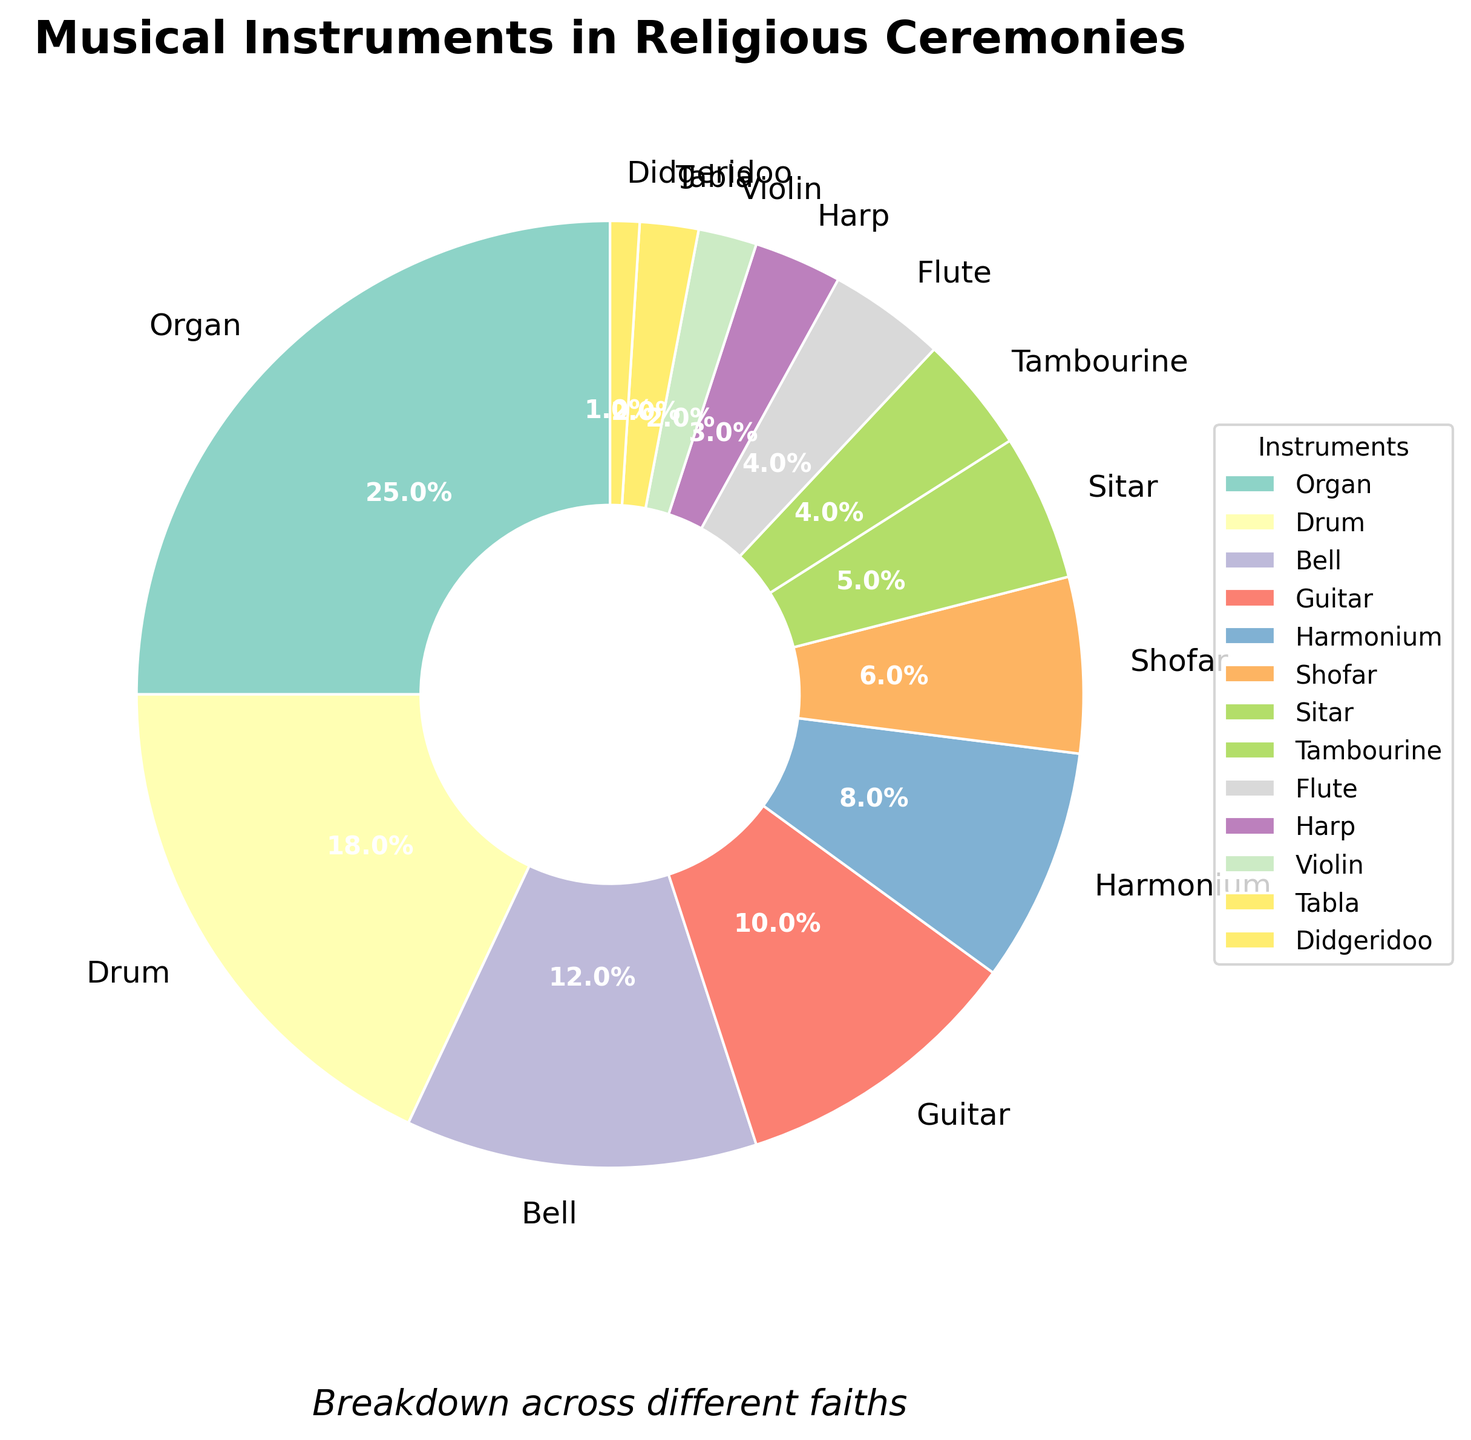What percentage of instruments used in religious ceremonies are percussion instruments (Drum, Tabla, Tambourine)? Add up the respective percentages for Drum (18%), Tabla (2%), and Tambourine (4%) to find the total percentage. 18 + 2 + 4 = 24%
Answer: 24% Which instrument is most commonly used in religious ceremonies based on the pie chart? The instrument with the highest percentage is the most commonly used. From the chart, the Organ has the highest percentage at 25%.
Answer: Organ How much greater is the percentage of Harmoniums compared to Sitars in religious ceremonies? Subtract the percentage of Sitars (5%) from the percentage of Harmoniums (8%). 8 - 5 = 3%
Answer: 3% Which two instruments together make up exactly 10% of the total share? From the chart, both Flute and Tambourine each contribute 4%, and Tabla contributes 2%, adding together to 10%.
Answer: Flute and Tambourine or Violin and Tabla How does the percentage usage of the Shofar compare with that of the Sitar? From the pie chart, the percentage usage of the Shofar (6%) is greater than that of the Sitar (5%). 6% - 5% = 1%
Answer: Shofar has 1% more What is the combined percentage for Bell and Guitar? Add the percentages for Bell (12%) and Guitar (10%). 12 + 10 = 22%
Answer: 22% Which instrument represents the smallest percentage of use in religious ceremonies? The instrument with the smallest percentage in the chart is the Didgeridoo with 1%.
Answer: Didgeridoo If we look at string instruments, which ones are included and what is their total percentage? Identify the string instruments: Guitar (10%), Sitar (5%), Harp (3%), Violin (2%). Their total percentage is 10 + 5 + 3 + 2 = 20%
Answer: Guitar, Sitar, Harp, Violin; 20% How many instruments have a single-digit percentage usage in religious ceremonies? Identify all instruments with percentages less than 10%. These are Harmonium (8%), Shofar (6%), Sitar (5%), Tambourine (4%), Flute (4%), Harp (3%), Violin (2%), Tabla (2%), Didgeridoo (1%). The total count is 9.
Answer: 9 instruments Which instruments have percentages within 4% of each other, based on their usage in religious ceremonies? Identify instruments within a 4% range: Drum (18%) and Bell (12%) are outside this range, but Guitar (10%), Harmonium (8%), Shofar (6%), and Sitar (5%) are all within 4% of each other.
Answer: Guitar, Harmonium, Shofar, Sitar 